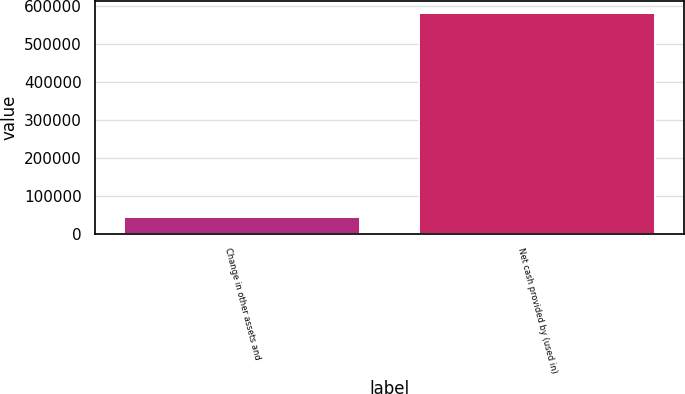Convert chart to OTSL. <chart><loc_0><loc_0><loc_500><loc_500><bar_chart><fcel>Change in other assets and<fcel>Net cash provided by (used in)<nl><fcel>45609<fcel>581516<nl></chart> 